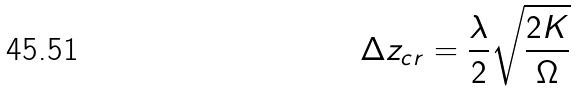<formula> <loc_0><loc_0><loc_500><loc_500>\Delta z _ { c r } = \frac { \lambda } { 2 } \sqrt { \frac { 2 K } { \Omega } }</formula> 